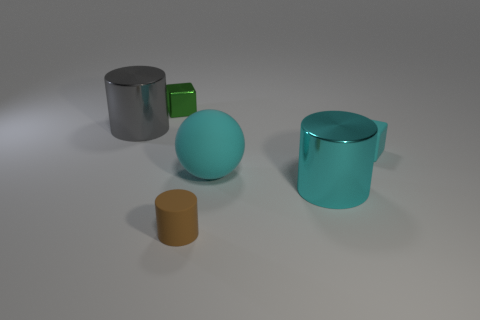Add 2 small brown rubber cylinders. How many objects exist? 8 Subtract all cyan cylinders. How many cylinders are left? 2 Subtract all balls. How many objects are left? 5 Subtract 1 spheres. How many spheres are left? 0 Add 6 green cubes. How many green cubes are left? 7 Add 3 small brown cylinders. How many small brown cylinders exist? 4 Subtract all green cubes. How many cubes are left? 1 Subtract 1 cyan cubes. How many objects are left? 5 Subtract all cyan cylinders. Subtract all green balls. How many cylinders are left? 2 Subtract all green cubes. How many gray cylinders are left? 1 